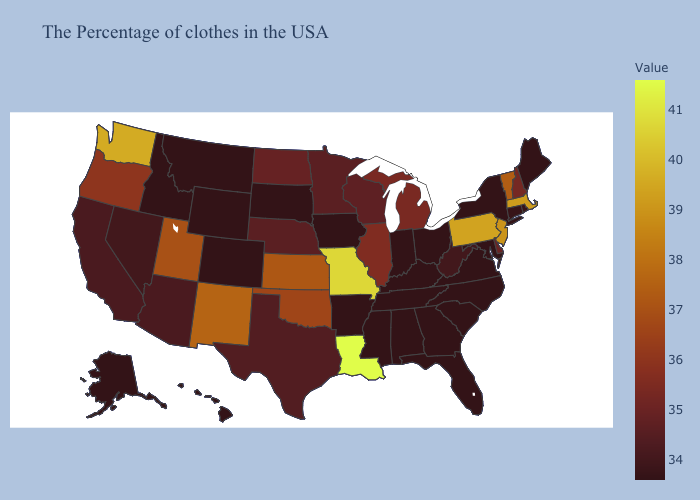Does New York have the highest value in the USA?
Quick response, please. No. Which states have the highest value in the USA?
Short answer required. Louisiana. Does New York have the lowest value in the Northeast?
Be succinct. Yes. 